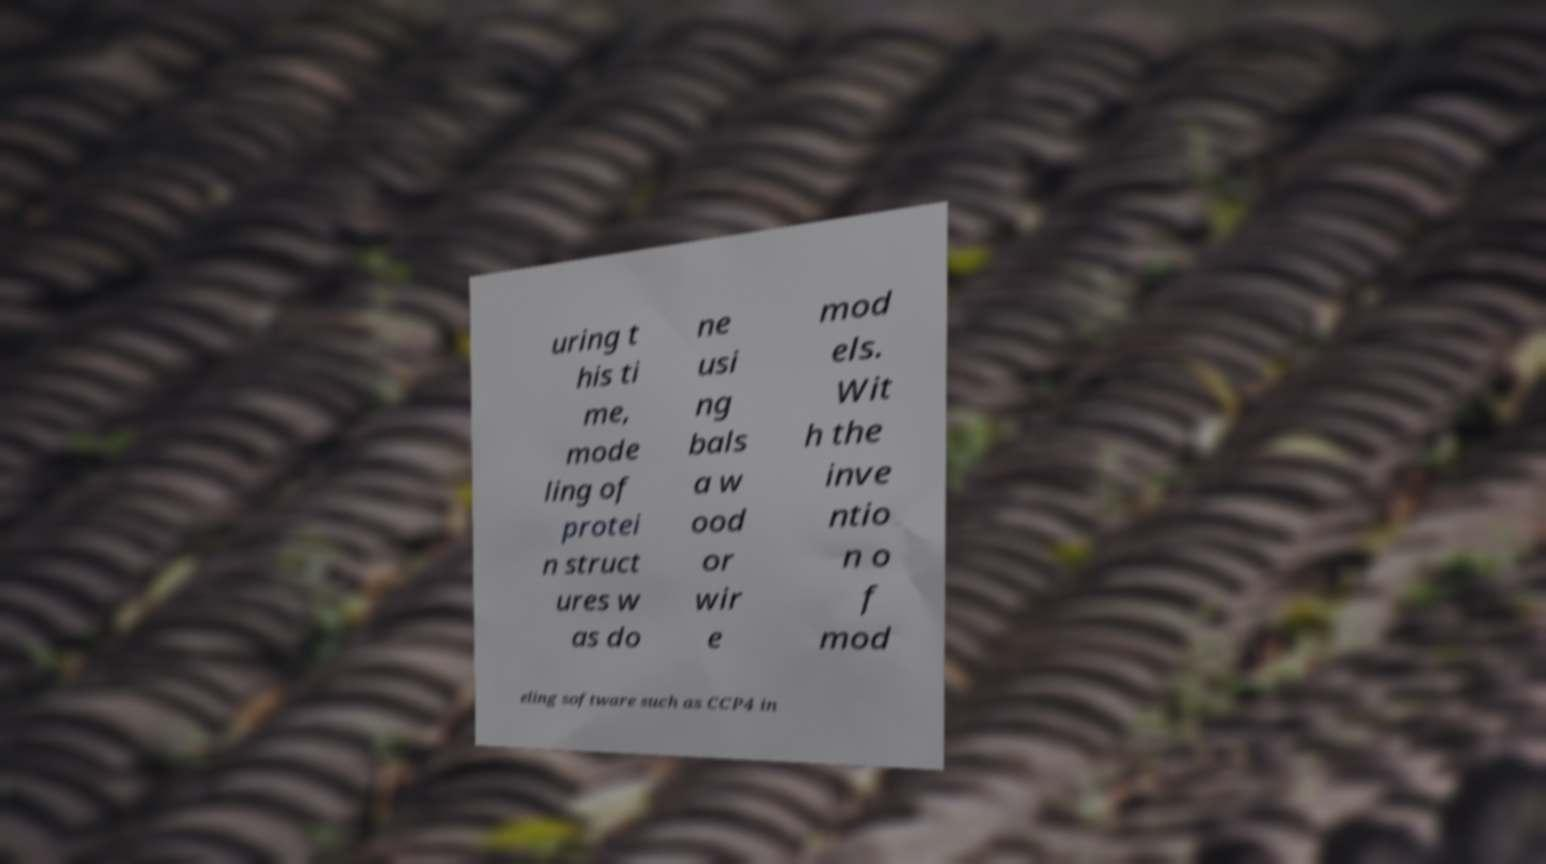For documentation purposes, I need the text within this image transcribed. Could you provide that? uring t his ti me, mode ling of protei n struct ures w as do ne usi ng bals a w ood or wir e mod els. Wit h the inve ntio n o f mod eling software such as CCP4 in 